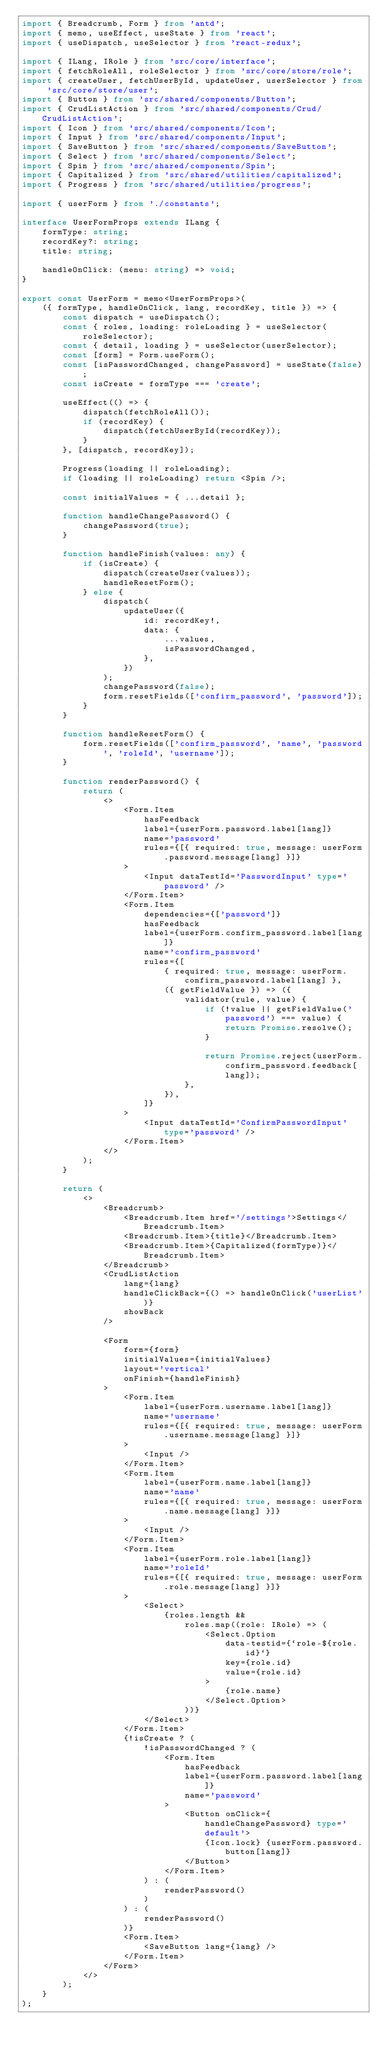Convert code to text. <code><loc_0><loc_0><loc_500><loc_500><_TypeScript_>import { Breadcrumb, Form } from 'antd';
import { memo, useEffect, useState } from 'react';
import { useDispatch, useSelector } from 'react-redux';

import { ILang, IRole } from 'src/core/interface';
import { fetchRoleAll, roleSelector } from 'src/core/store/role';
import { createUser, fetchUserById, updateUser, userSelector } from 'src/core/store/user';
import { Button } from 'src/shared/components/Button';
import { CrudListAction } from 'src/shared/components/Crud/CrudListAction';
import { Icon } from 'src/shared/components/Icon';
import { Input } from 'src/shared/components/Input';
import { SaveButton } from 'src/shared/components/SaveButton';
import { Select } from 'src/shared/components/Select';
import { Spin } from 'src/shared/components/Spin';
import { Capitalized } from 'src/shared/utilities/capitalized';
import { Progress } from 'src/shared/utilities/progress';

import { userForm } from './constants';

interface UserFormProps extends ILang {
    formType: string;
    recordKey?: string;
    title: string;

    handleOnClick: (menu: string) => void;
}

export const UserForm = memo<UserFormProps>(
    ({ formType, handleOnClick, lang, recordKey, title }) => {
        const dispatch = useDispatch();
        const { roles, loading: roleLoading } = useSelector(roleSelector);
        const { detail, loading } = useSelector(userSelector);
        const [form] = Form.useForm();
        const [isPasswordChanged, changePassword] = useState(false);
        const isCreate = formType === 'create';

        useEffect(() => {
            dispatch(fetchRoleAll());
            if (recordKey) {
                dispatch(fetchUserById(recordKey));
            }
        }, [dispatch, recordKey]);

        Progress(loading || roleLoading);
        if (loading || roleLoading) return <Spin />;

        const initialValues = { ...detail };

        function handleChangePassword() {
            changePassword(true);
        }

        function handleFinish(values: any) {
            if (isCreate) {
                dispatch(createUser(values));
                handleResetForm();
            } else {
                dispatch(
                    updateUser({
                        id: recordKey!,
                        data: {
                            ...values,
                            isPasswordChanged,
                        },
                    })
                );
                changePassword(false);
                form.resetFields(['confirm_password', 'password']);
            }
        }

        function handleResetForm() {
            form.resetFields(['confirm_password', 'name', 'password', 'roleId', 'username']);
        }

        function renderPassword() {
            return (
                <>
                    <Form.Item
                        hasFeedback
                        label={userForm.password.label[lang]}
                        name='password'
                        rules={[{ required: true, message: userForm.password.message[lang] }]}
                    >
                        <Input dataTestId='PasswordInput' type='password' />
                    </Form.Item>
                    <Form.Item
                        dependencies={['password']}
                        hasFeedback
                        label={userForm.confirm_password.label[lang]}
                        name='confirm_password'
                        rules={[
                            { required: true, message: userForm.confirm_password.label[lang] },
                            ({ getFieldValue }) => ({
                                validator(rule, value) {
                                    if (!value || getFieldValue('password') === value) {
                                        return Promise.resolve();
                                    }

                                    return Promise.reject(userForm.confirm_password.feedback[lang]);
                                },
                            }),
                        ]}
                    >
                        <Input dataTestId='ConfirmPasswordInput' type='password' />
                    </Form.Item>
                </>
            );
        }

        return (
            <>
                <Breadcrumb>
                    <Breadcrumb.Item href='/settings'>Settings</Breadcrumb.Item>
                    <Breadcrumb.Item>{title}</Breadcrumb.Item>
                    <Breadcrumb.Item>{Capitalized(formType)}</Breadcrumb.Item>
                </Breadcrumb>
                <CrudListAction
                    lang={lang}
                    handleClickBack={() => handleOnClick('userList')}
                    showBack
                />

                <Form
                    form={form}
                    initialValues={initialValues}
                    layout='vertical'
                    onFinish={handleFinish}
                >
                    <Form.Item
                        label={userForm.username.label[lang]}
                        name='username'
                        rules={[{ required: true, message: userForm.username.message[lang] }]}
                    >
                        <Input />
                    </Form.Item>
                    <Form.Item
                        label={userForm.name.label[lang]}
                        name='name'
                        rules={[{ required: true, message: userForm.name.message[lang] }]}
                    >
                        <Input />
                    </Form.Item>
                    <Form.Item
                        label={userForm.role.label[lang]}
                        name='roleId'
                        rules={[{ required: true, message: userForm.role.message[lang] }]}
                    >
                        <Select>
                            {roles.length &&
                                roles.map((role: IRole) => (
                                    <Select.Option
                                        data-testid={`role-${role.id}`}
                                        key={role.id}
                                        value={role.id}
                                    >
                                        {role.name}
                                    </Select.Option>
                                ))}
                        </Select>
                    </Form.Item>
                    {!isCreate ? (
                        !isPasswordChanged ? (
                            <Form.Item
                                hasFeedback
                                label={userForm.password.label[lang]}
                                name='password'
                            >
                                <Button onClick={handleChangePassword} type='default'>
                                    {Icon.lock} {userForm.password.button[lang]}
                                </Button>
                            </Form.Item>
                        ) : (
                            renderPassword()
                        )
                    ) : (
                        renderPassword()
                    )}
                    <Form.Item>
                        <SaveButton lang={lang} />
                    </Form.Item>
                </Form>
            </>
        );
    }
);
</code> 